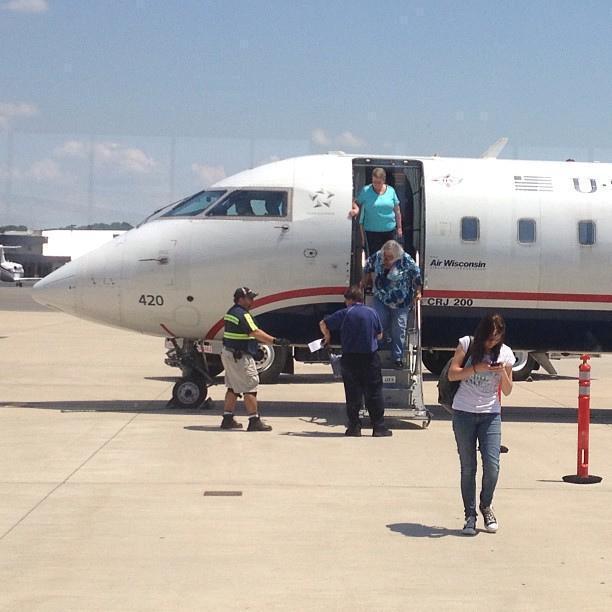What is the woman in the white shirt using in her hands?
Make your selection and explain in format: 'Answer: answer
Rationale: rationale.'
Options: Calculator, makeup, gameboy, phone. Answer: phone.
Rationale: The woman is looking at her phone. 